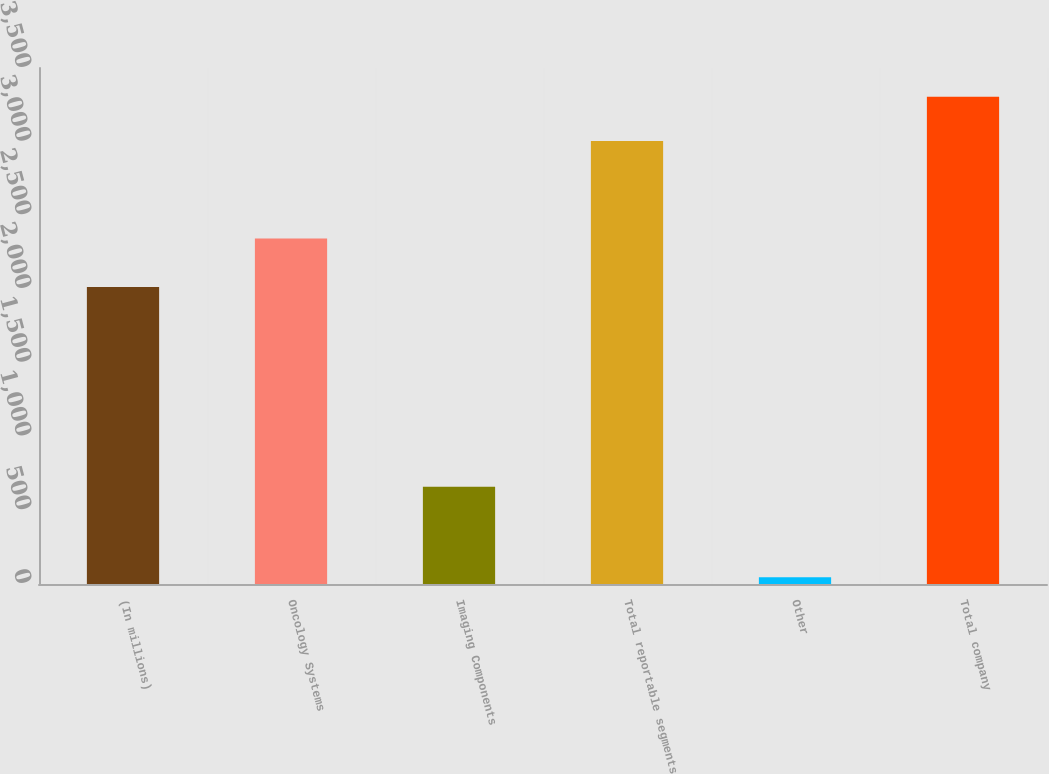<chart> <loc_0><loc_0><loc_500><loc_500><bar_chart><fcel>(In millions)<fcel>Oncology Systems<fcel>Imaging Components<fcel>Total reportable segments<fcel>Other<fcel>Total company<nl><fcel>2014<fcel>2344.2<fcel>660.2<fcel>3004.4<fcel>45.4<fcel>3304.84<nl></chart> 